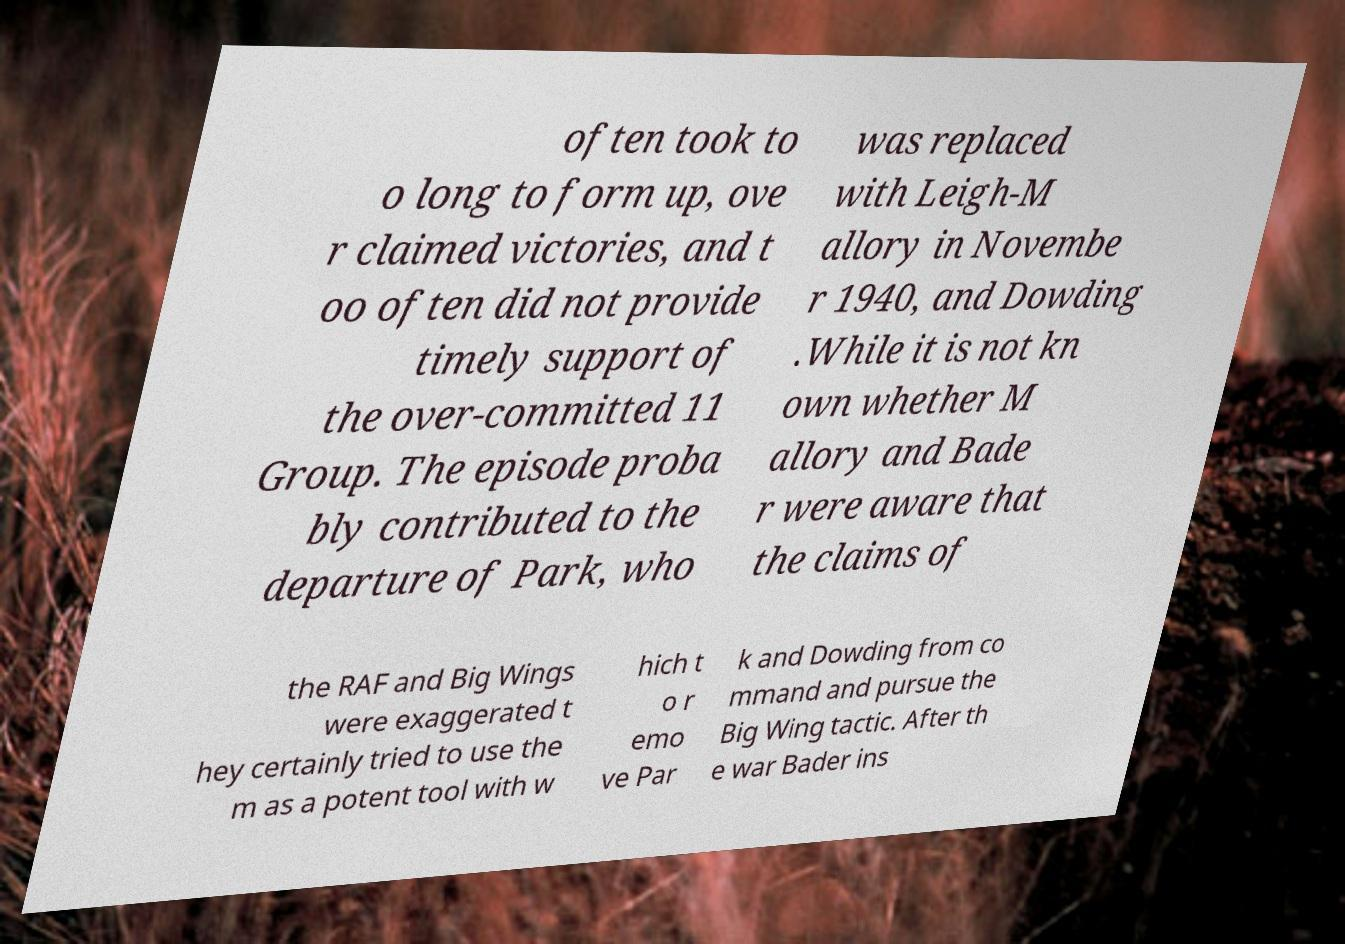Could you assist in decoding the text presented in this image and type it out clearly? often took to o long to form up, ove r claimed victories, and t oo often did not provide timely support of the over-committed 11 Group. The episode proba bly contributed to the departure of Park, who was replaced with Leigh-M allory in Novembe r 1940, and Dowding .While it is not kn own whether M allory and Bade r were aware that the claims of the RAF and Big Wings were exaggerated t hey certainly tried to use the m as a potent tool with w hich t o r emo ve Par k and Dowding from co mmand and pursue the Big Wing tactic. After th e war Bader ins 